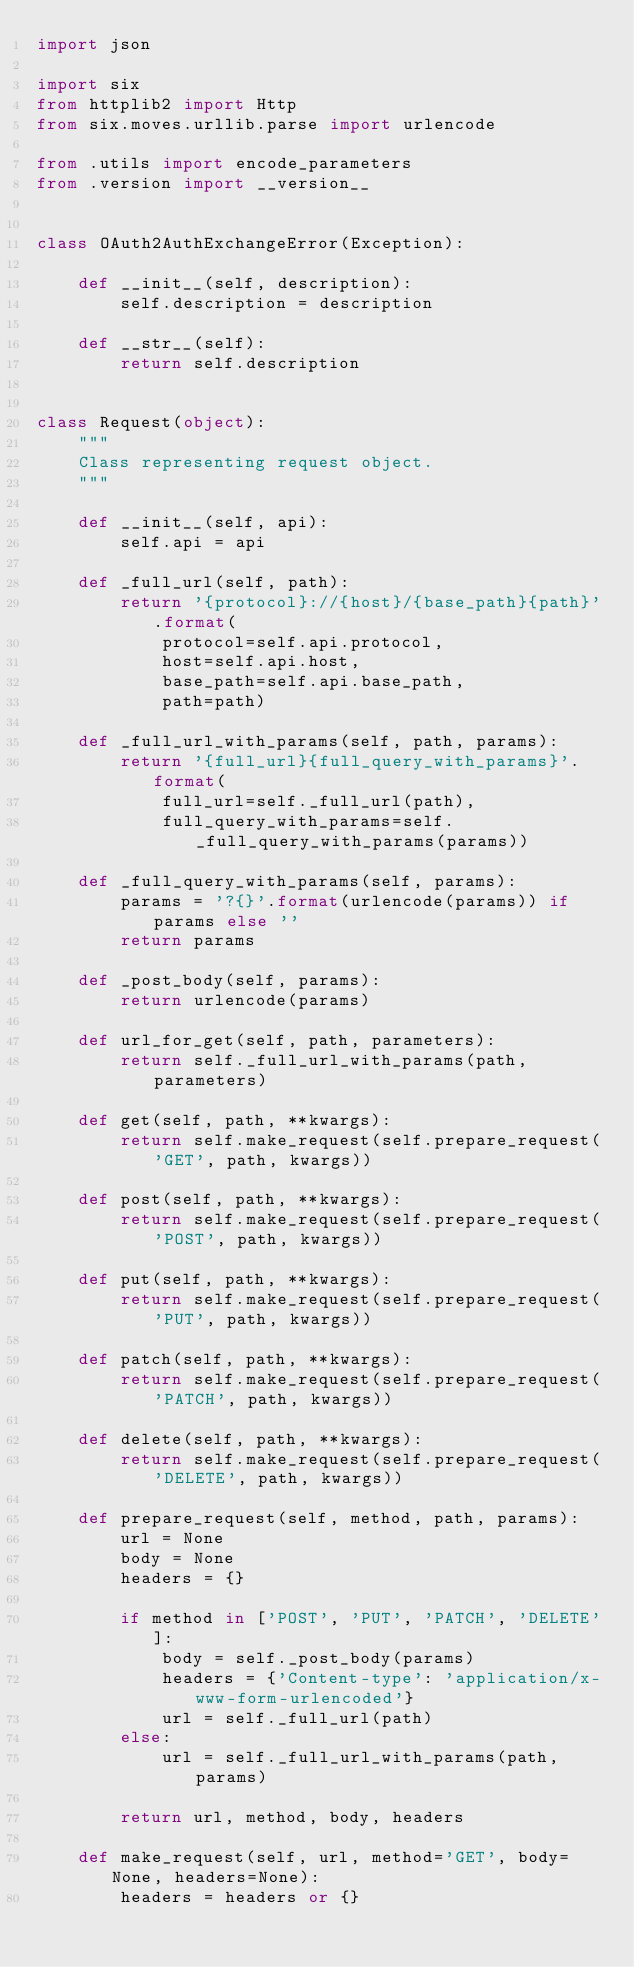Convert code to text. <code><loc_0><loc_0><loc_500><loc_500><_Python_>import json

import six
from httplib2 import Http
from six.moves.urllib.parse import urlencode

from .utils import encode_parameters
from .version import __version__


class OAuth2AuthExchangeError(Exception):

    def __init__(self, description):
        self.description = description

    def __str__(self):
        return self.description


class Request(object):
    """
    Class representing request object.
    """

    def __init__(self, api):
        self.api = api

    def _full_url(self, path):
        return '{protocol}://{host}/{base_path}{path}'.format(
            protocol=self.api.protocol,
            host=self.api.host,
            base_path=self.api.base_path,
            path=path)

    def _full_url_with_params(self, path, params):
        return '{full_url}{full_query_with_params}'.format(
            full_url=self._full_url(path),
            full_query_with_params=self._full_query_with_params(params))

    def _full_query_with_params(self, params):
        params = '?{}'.format(urlencode(params)) if params else ''
        return params

    def _post_body(self, params):
        return urlencode(params)

    def url_for_get(self, path, parameters):
        return self._full_url_with_params(path, parameters)

    def get(self, path, **kwargs):
        return self.make_request(self.prepare_request('GET', path, kwargs))

    def post(self, path, **kwargs):
        return self.make_request(self.prepare_request('POST', path, kwargs))

    def put(self, path, **kwargs):
        return self.make_request(self.prepare_request('PUT', path, kwargs))

    def patch(self, path, **kwargs):
        return self.make_request(self.prepare_request('PATCH', path, kwargs))

    def delete(self, path, **kwargs):
        return self.make_request(self.prepare_request('DELETE', path, kwargs))

    def prepare_request(self, method, path, params):
        url = None
        body = None
        headers = {}

        if method in ['POST', 'PUT', 'PATCH', 'DELETE']:
            body = self._post_body(params)
            headers = {'Content-type': 'application/x-www-form-urlencoded'}
            url = self._full_url(path)
        else:
            url = self._full_url_with_params(path, params)

        return url, method, body, headers

    def make_request(self, url, method='GET', body=None, headers=None):
        headers = headers or {}</code> 